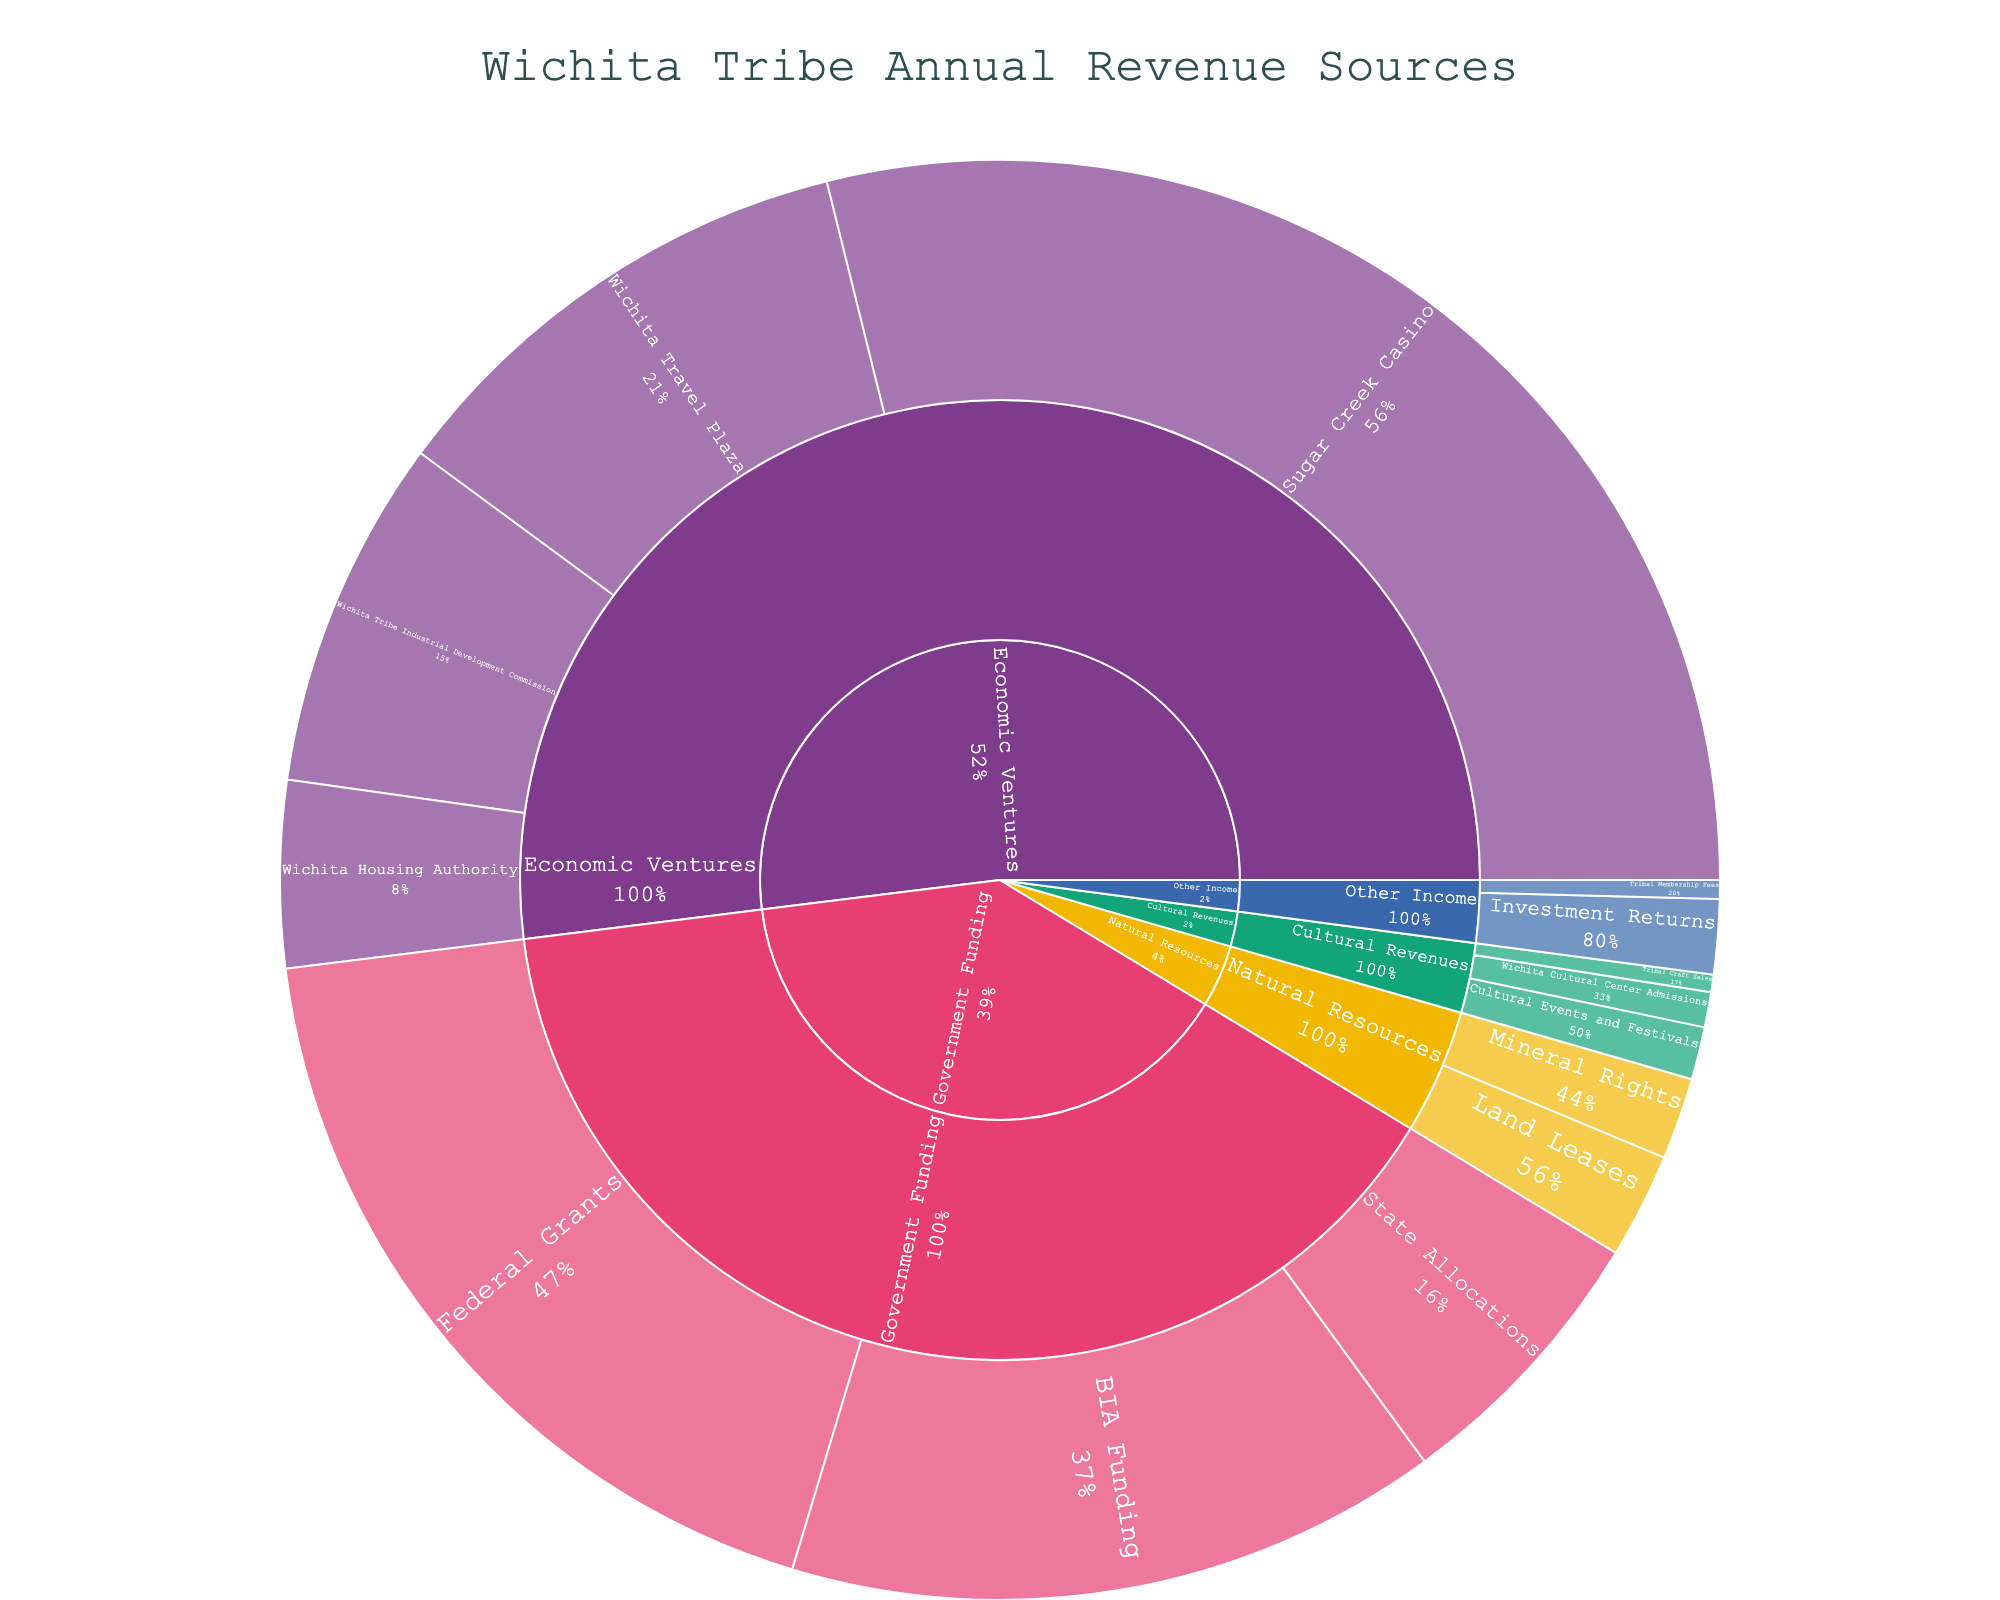What category has the highest overall value? The Sunburst Plot's segments represent different revenue categories, and the largest segment corresponds to the category with the highest value.
Answer: Economic Ventures Which subcategory in Government Funding has the lowest value? In the Government Funding category, compare the values of Federal Grants, State Allocations, and BIA Funding.
Answer: State Allocations What is the total value of all Cultural Revenues? Sum the values of Wichita Cultural Center Admissions, Tribal Craft Sales, and Cultural Events and Festivals. 150,000 + 75,000 + 225,000 = 450,000
Answer: 450,000 Which generates more revenue: Sugar Creek Casino or Wichita Travel Plaza? Compare the value segments for Sugar Creek Casino and Wichita Travel Plaza within the Economic Ventures category.
Answer: Sugar Creek Casino What percentage of the Government Funding category does BIA Funding represent? Calculate the percentage by dividing BIA Funding's value by the total value of Government Funding and multiplying by 100. (2,800,000 / (3,500,000 + 1,200,000 + 2,800,000)) * 100 ≈ 40.58%
Answer: ~40.58% Which categories have more revenue than 'Natural Resources'? Identify categories with values larger than the combined value of Land Leases and Mineral Rights in Natural Resources. Economic Ventures, Government Funding
Answer: Economic Ventures, Government Funding What is the combined value of Tribal Membership Fees and Investment Returns? Sum the values of Tribal Membership Fees and Investment Returns from the Other Income category. 80,000 + 320,000 = 400,000
Answer: 400,000 What portion of total revenue comes from Economic Ventures? Calculate the percentage by dividing Economic Ventures' total value by the sum of all categories' values. ((2,100,000 + 5,500,000 + 800,000 + 1,500,000) / Total Revenue)
Answer: ~65.52% 